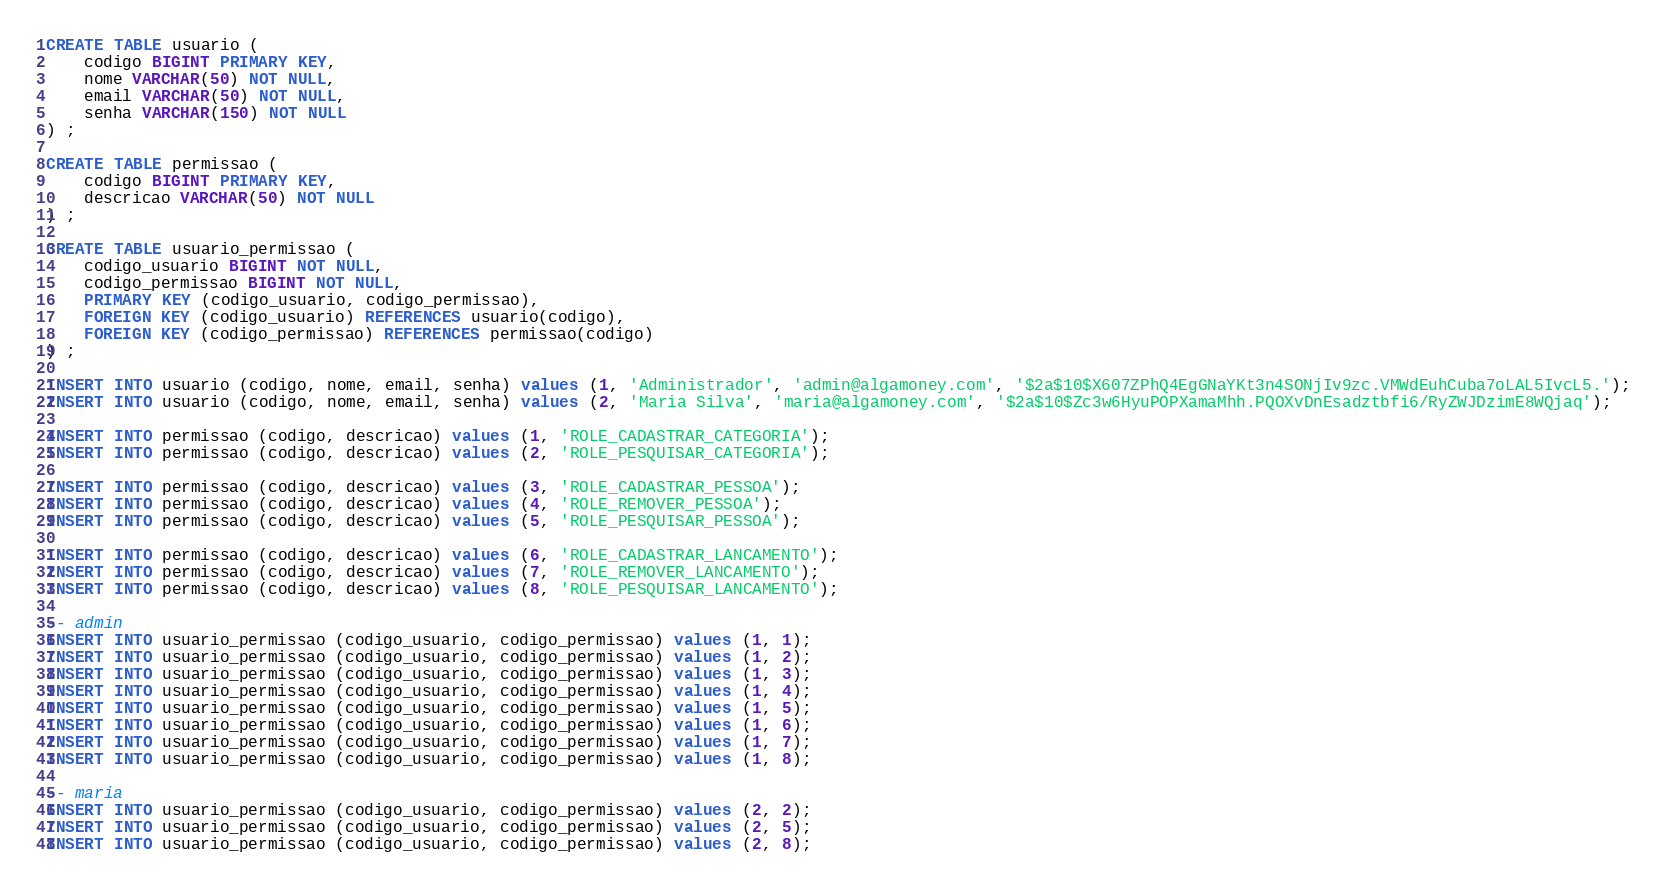<code> <loc_0><loc_0><loc_500><loc_500><_SQL_>CREATE TABLE usuario (
	codigo BIGINT PRIMARY KEY,
	nome VARCHAR(50) NOT NULL,
	email VARCHAR(50) NOT NULL,
	senha VARCHAR(150) NOT NULL
) ;

CREATE TABLE permissao (
	codigo BIGINT PRIMARY KEY,
	descricao VARCHAR(50) NOT NULL
) ;

CREATE TABLE usuario_permissao (
	codigo_usuario BIGINT NOT NULL,
	codigo_permissao BIGINT NOT NULL,
	PRIMARY KEY (codigo_usuario, codigo_permissao),
	FOREIGN KEY (codigo_usuario) REFERENCES usuario(codigo),
	FOREIGN KEY (codigo_permissao) REFERENCES permissao(codigo)
) ;

INSERT INTO usuario (codigo, nome, email, senha) values (1, 'Administrador', 'admin@algamoney.com', '$2a$10$X607ZPhQ4EgGNaYKt3n4SONjIv9zc.VMWdEuhCuba7oLAL5IvcL5.');
INSERT INTO usuario (codigo, nome, email, senha) values (2, 'Maria Silva', 'maria@algamoney.com', '$2a$10$Zc3w6HyuPOPXamaMhh.PQOXvDnEsadztbfi6/RyZWJDzimE8WQjaq');

INSERT INTO permissao (codigo, descricao) values (1, 'ROLE_CADASTRAR_CATEGORIA');
INSERT INTO permissao (codigo, descricao) values (2, 'ROLE_PESQUISAR_CATEGORIA');

INSERT INTO permissao (codigo, descricao) values (3, 'ROLE_CADASTRAR_PESSOA');
INSERT INTO permissao (codigo, descricao) values (4, 'ROLE_REMOVER_PESSOA');
INSERT INTO permissao (codigo, descricao) values (5, 'ROLE_PESQUISAR_PESSOA');

INSERT INTO permissao (codigo, descricao) values (6, 'ROLE_CADASTRAR_LANCAMENTO');
INSERT INTO permissao (codigo, descricao) values (7, 'ROLE_REMOVER_LANCAMENTO');
INSERT INTO permissao (codigo, descricao) values (8, 'ROLE_PESQUISAR_LANCAMENTO');

-- admin
INSERT INTO usuario_permissao (codigo_usuario, codigo_permissao) values (1, 1);
INSERT INTO usuario_permissao (codigo_usuario, codigo_permissao) values (1, 2);
INSERT INTO usuario_permissao (codigo_usuario, codigo_permissao) values (1, 3);
INSERT INTO usuario_permissao (codigo_usuario, codigo_permissao) values (1, 4);
INSERT INTO usuario_permissao (codigo_usuario, codigo_permissao) values (1, 5);
INSERT INTO usuario_permissao (codigo_usuario, codigo_permissao) values (1, 6);
INSERT INTO usuario_permissao (codigo_usuario, codigo_permissao) values (1, 7);
INSERT INTO usuario_permissao (codigo_usuario, codigo_permissao) values (1, 8);

-- maria
INSERT INTO usuario_permissao (codigo_usuario, codigo_permissao) values (2, 2);
INSERT INTO usuario_permissao (codigo_usuario, codigo_permissao) values (2, 5);
INSERT INTO usuario_permissao (codigo_usuario, codigo_permissao) values (2, 8);
</code> 